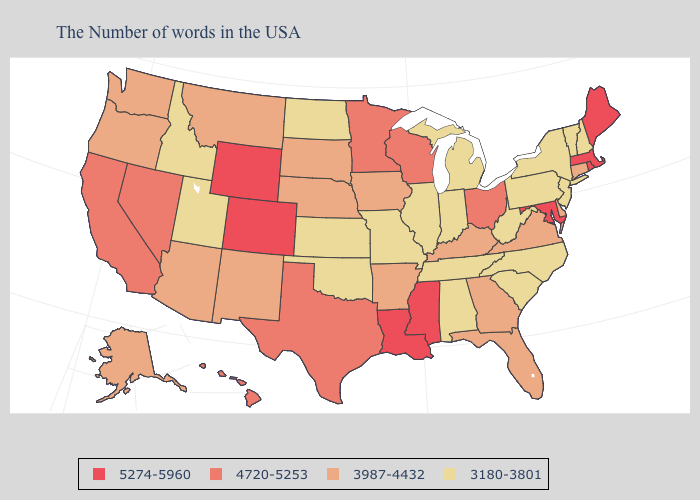Name the states that have a value in the range 4720-5253?
Answer briefly. Ohio, Wisconsin, Minnesota, Texas, Nevada, California, Hawaii. Which states have the lowest value in the South?
Quick response, please. North Carolina, South Carolina, West Virginia, Alabama, Tennessee, Oklahoma. Which states have the highest value in the USA?
Be succinct. Maine, Massachusetts, Rhode Island, Maryland, Mississippi, Louisiana, Wyoming, Colorado. Does Louisiana have the same value as New Hampshire?
Short answer required. No. Is the legend a continuous bar?
Concise answer only. No. What is the value of Maine?
Concise answer only. 5274-5960. Does Colorado have the same value as Massachusetts?
Concise answer only. Yes. What is the value of Virginia?
Quick response, please. 3987-4432. Which states have the lowest value in the USA?
Give a very brief answer. New Hampshire, Vermont, New York, New Jersey, Pennsylvania, North Carolina, South Carolina, West Virginia, Michigan, Indiana, Alabama, Tennessee, Illinois, Missouri, Kansas, Oklahoma, North Dakota, Utah, Idaho. What is the highest value in states that border Tennessee?
Write a very short answer. 5274-5960. Name the states that have a value in the range 3180-3801?
Be succinct. New Hampshire, Vermont, New York, New Jersey, Pennsylvania, North Carolina, South Carolina, West Virginia, Michigan, Indiana, Alabama, Tennessee, Illinois, Missouri, Kansas, Oklahoma, North Dakota, Utah, Idaho. Name the states that have a value in the range 3180-3801?
Keep it brief. New Hampshire, Vermont, New York, New Jersey, Pennsylvania, North Carolina, South Carolina, West Virginia, Michigan, Indiana, Alabama, Tennessee, Illinois, Missouri, Kansas, Oklahoma, North Dakota, Utah, Idaho. What is the highest value in the USA?
Quick response, please. 5274-5960. Among the states that border Utah , which have the highest value?
Keep it brief. Wyoming, Colorado. 